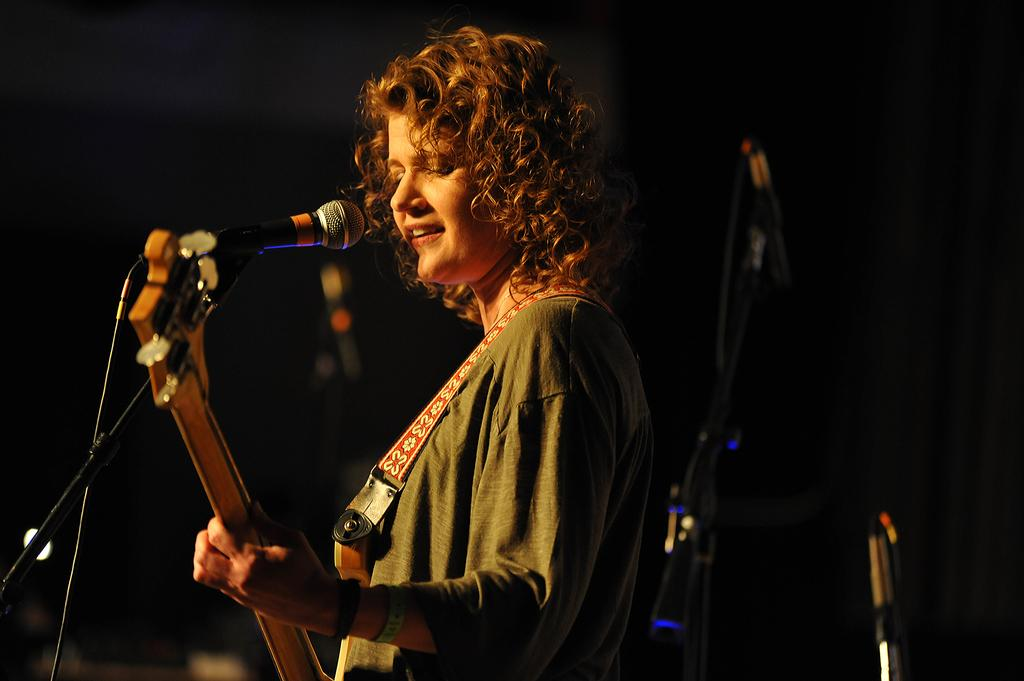What is the woman in the image doing? The woman is playing a guitar and singing. What object is present in the image that is typically used for amplifying sound? There is a microphone in the image. What type of dirt can be seen on the island in the image? There is no dirt or island present in the image; it features a woman playing a guitar and singing with a microphone. What type of porter is assisting the woman in the image? There is no porter present in the image. 